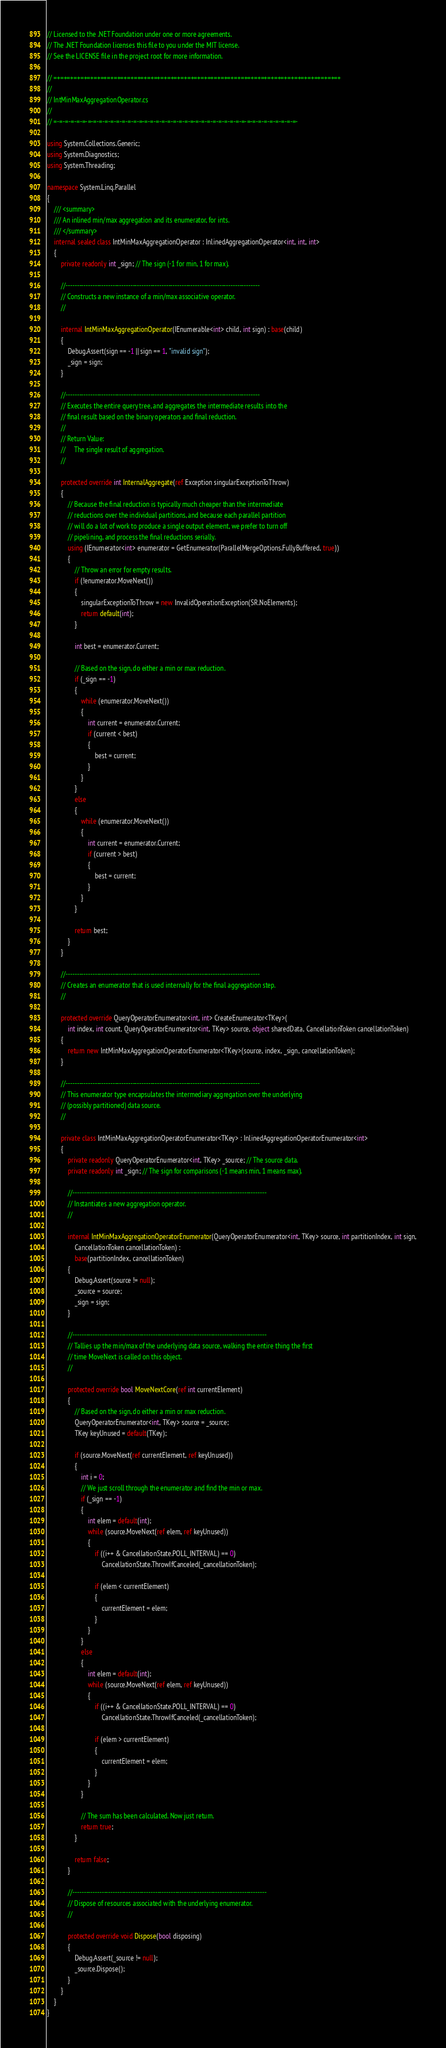Convert code to text. <code><loc_0><loc_0><loc_500><loc_500><_C#_>// Licensed to the .NET Foundation under one or more agreements.
// The .NET Foundation licenses this file to you under the MIT license.
// See the LICENSE file in the project root for more information.

// =+=+=+=+=+=+=+=+=+=+=+=+=+=+=+=+=+=+=+=+=+=+=+=+=+=+=+=+=+=+=+=+=+=+=+=+=+=+=+=+=+=+=+
//
// IntMinMaxAggregationOperator.cs
//
// =-=-=-=-=-=-=-=-=-=-=-=-=-=-=-=-=-=-=-=-=-=-=-=-=-=-=-=-=-=-=-=-=-=-=-=-=-=-=-=-=-=-=-

using System.Collections.Generic;
using System.Diagnostics;
using System.Threading;

namespace System.Linq.Parallel
{
    /// <summary>
    /// An inlined min/max aggregation and its enumerator, for ints. 
    /// </summary>
    internal sealed class IntMinMaxAggregationOperator : InlinedAggregationOperator<int, int, int>
    {
        private readonly int _sign; // The sign (-1 for min, 1 for max).

        //---------------------------------------------------------------------------------------
        // Constructs a new instance of a min/max associative operator.
        //

        internal IntMinMaxAggregationOperator(IEnumerable<int> child, int sign) : base(child)
        {
            Debug.Assert(sign == -1 || sign == 1, "invalid sign");
            _sign = sign;
        }

        //---------------------------------------------------------------------------------------
        // Executes the entire query tree, and aggregates the intermediate results into the
        // final result based on the binary operators and final reduction.
        //
        // Return Value:
        //     The single result of aggregation.
        //

        protected override int InternalAggregate(ref Exception singularExceptionToThrow)
        {
            // Because the final reduction is typically much cheaper than the intermediate 
            // reductions over the individual partitions, and because each parallel partition
            // will do a lot of work to produce a single output element, we prefer to turn off
            // pipelining, and process the final reductions serially.
            using (IEnumerator<int> enumerator = GetEnumerator(ParallelMergeOptions.FullyBuffered, true))
            {
                // Throw an error for empty results.
                if (!enumerator.MoveNext())
                {
                    singularExceptionToThrow = new InvalidOperationException(SR.NoElements);
                    return default(int);
                }

                int best = enumerator.Current;

                // Based on the sign, do either a min or max reduction.
                if (_sign == -1)
                {
                    while (enumerator.MoveNext())
                    {
                        int current = enumerator.Current;
                        if (current < best)
                        {
                            best = current;
                        }
                    }
                }
                else
                {
                    while (enumerator.MoveNext())
                    {
                        int current = enumerator.Current;
                        if (current > best)
                        {
                            best = current;
                        }
                    }
                }

                return best;
            }
        }

        //---------------------------------------------------------------------------------------
        // Creates an enumerator that is used internally for the final aggregation step.
        //

        protected override QueryOperatorEnumerator<int, int> CreateEnumerator<TKey>(
            int index, int count, QueryOperatorEnumerator<int, TKey> source, object sharedData, CancellationToken cancellationToken)
        {
            return new IntMinMaxAggregationOperatorEnumerator<TKey>(source, index, _sign, cancellationToken);
        }

        //---------------------------------------------------------------------------------------
        // This enumerator type encapsulates the intermediary aggregation over the underlying
        // (possibly partitioned) data source.
        //

        private class IntMinMaxAggregationOperatorEnumerator<TKey> : InlinedAggregationOperatorEnumerator<int>
        {
            private readonly QueryOperatorEnumerator<int, TKey> _source; // The source data.
            private readonly int _sign; // The sign for comparisons (-1 means min, 1 means max).

            //---------------------------------------------------------------------------------------
            // Instantiates a new aggregation operator.
            //

            internal IntMinMaxAggregationOperatorEnumerator(QueryOperatorEnumerator<int, TKey> source, int partitionIndex, int sign,
                CancellationToken cancellationToken) :
                base(partitionIndex, cancellationToken)
            {
                Debug.Assert(source != null);
                _source = source;
                _sign = sign;
            }

            //---------------------------------------------------------------------------------------
            // Tallies up the min/max of the underlying data source, walking the entire thing the first
            // time MoveNext is called on this object.
            //

            protected override bool MoveNextCore(ref int currentElement)
            {
                // Based on the sign, do either a min or max reduction.
                QueryOperatorEnumerator<int, TKey> source = _source;
                TKey keyUnused = default(TKey);

                if (source.MoveNext(ref currentElement, ref keyUnused))
                {
                    int i = 0;
                    // We just scroll through the enumerator and find the min or max.
                    if (_sign == -1)
                    {
                        int elem = default(int);
                        while (source.MoveNext(ref elem, ref keyUnused))
                        {
                            if ((i++ & CancellationState.POLL_INTERVAL) == 0)
                                CancellationState.ThrowIfCanceled(_cancellationToken);

                            if (elem < currentElement)
                            {
                                currentElement = elem;
                            }
                        }
                    }
                    else
                    {
                        int elem = default(int);
                        while (source.MoveNext(ref elem, ref keyUnused))
                        {
                            if ((i++ & CancellationState.POLL_INTERVAL) == 0)
                                CancellationState.ThrowIfCanceled(_cancellationToken);

                            if (elem > currentElement)
                            {
                                currentElement = elem;
                            }
                        }
                    }

                    // The sum has been calculated. Now just return.
                    return true;
                }

                return false;
            }

            //---------------------------------------------------------------------------------------
            // Dispose of resources associated with the underlying enumerator.
            //

            protected override void Dispose(bool disposing)
            {
                Debug.Assert(_source != null);
                _source.Dispose();
            }
        }
    }
}
</code> 